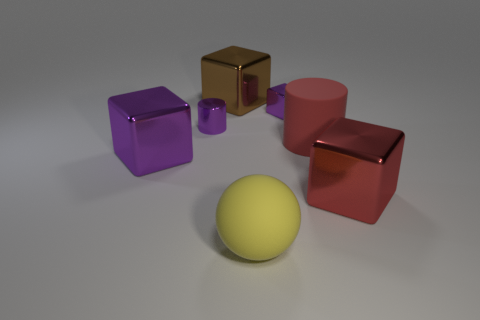Subtract all gray cubes. Subtract all red cylinders. How many cubes are left? 4 Add 2 rubber cylinders. How many objects exist? 9 Subtract all cylinders. How many objects are left? 5 Add 4 small red shiny objects. How many small red shiny objects exist? 4 Subtract 0 gray blocks. How many objects are left? 7 Subtract all big rubber balls. Subtract all large purple things. How many objects are left? 5 Add 4 large red matte objects. How many large red matte objects are left? 5 